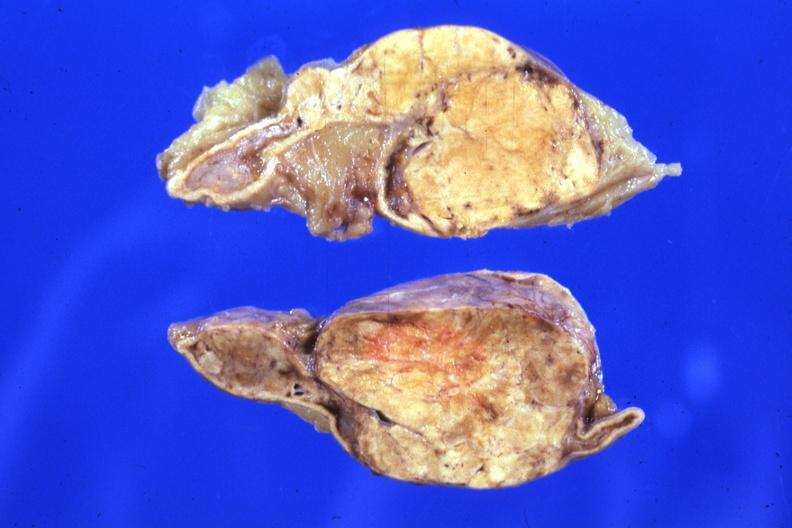how is fixed tissue sectioned gland rather lesion?
Answer the question using a single word or phrase. Large 